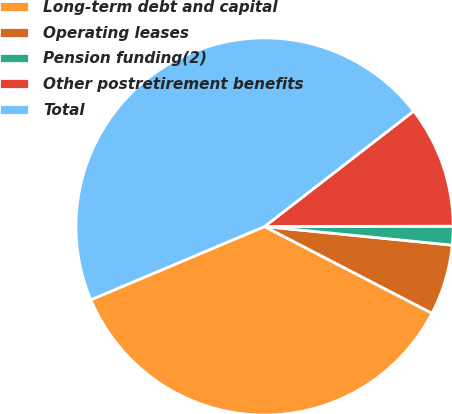Convert chart to OTSL. <chart><loc_0><loc_0><loc_500><loc_500><pie_chart><fcel>Long-term debt and capital<fcel>Operating leases<fcel>Pension funding(2)<fcel>Other postretirement benefits<fcel>Total<nl><fcel>36.04%<fcel>6.03%<fcel>1.6%<fcel>10.46%<fcel>45.87%<nl></chart> 